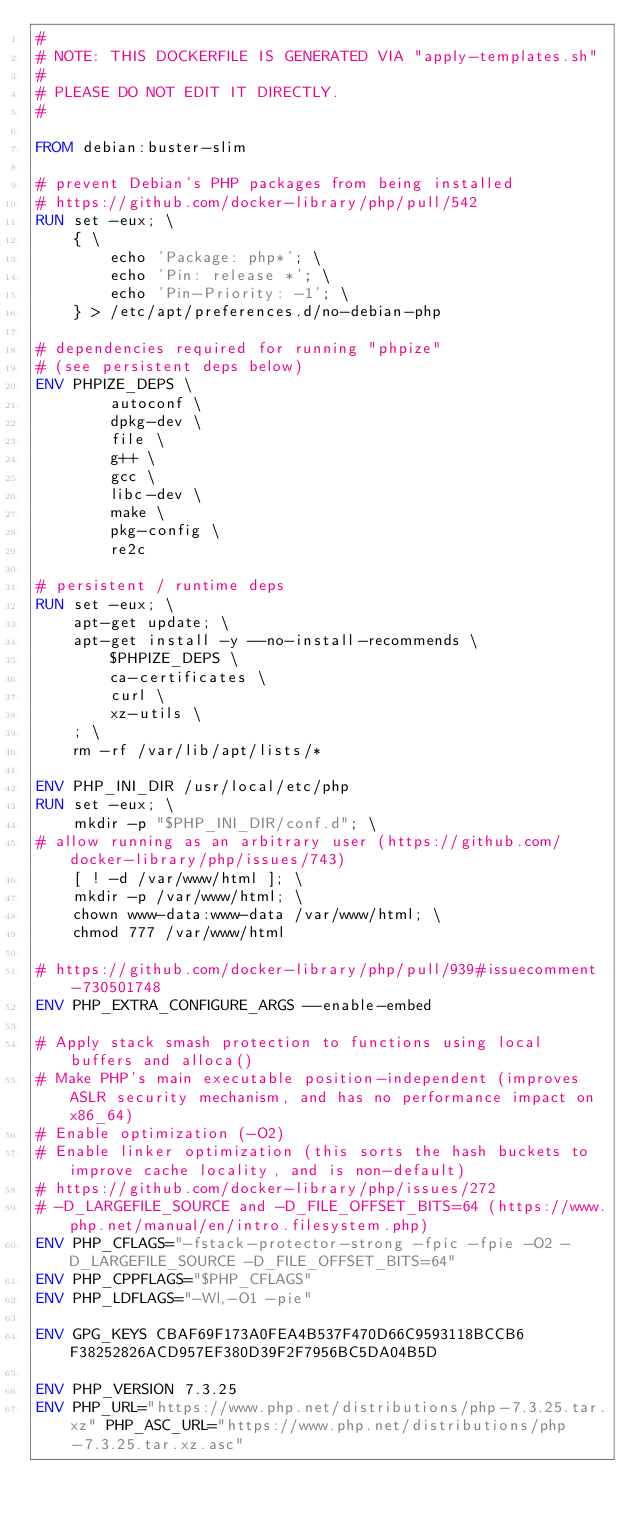<code> <loc_0><loc_0><loc_500><loc_500><_Dockerfile_>#
# NOTE: THIS DOCKERFILE IS GENERATED VIA "apply-templates.sh"
#
# PLEASE DO NOT EDIT IT DIRECTLY.
#

FROM debian:buster-slim

# prevent Debian's PHP packages from being installed
# https://github.com/docker-library/php/pull/542
RUN set -eux; \
	{ \
		echo 'Package: php*'; \
		echo 'Pin: release *'; \
		echo 'Pin-Priority: -1'; \
	} > /etc/apt/preferences.d/no-debian-php

# dependencies required for running "phpize"
# (see persistent deps below)
ENV PHPIZE_DEPS \
		autoconf \
		dpkg-dev \
		file \
		g++ \
		gcc \
		libc-dev \
		make \
		pkg-config \
		re2c

# persistent / runtime deps
RUN set -eux; \
	apt-get update; \
	apt-get install -y --no-install-recommends \
		$PHPIZE_DEPS \
		ca-certificates \
		curl \
		xz-utils \
	; \
	rm -rf /var/lib/apt/lists/*

ENV PHP_INI_DIR /usr/local/etc/php
RUN set -eux; \
	mkdir -p "$PHP_INI_DIR/conf.d"; \
# allow running as an arbitrary user (https://github.com/docker-library/php/issues/743)
	[ ! -d /var/www/html ]; \
	mkdir -p /var/www/html; \
	chown www-data:www-data /var/www/html; \
	chmod 777 /var/www/html

# https://github.com/docker-library/php/pull/939#issuecomment-730501748
ENV PHP_EXTRA_CONFIGURE_ARGS --enable-embed

# Apply stack smash protection to functions using local buffers and alloca()
# Make PHP's main executable position-independent (improves ASLR security mechanism, and has no performance impact on x86_64)
# Enable optimization (-O2)
# Enable linker optimization (this sorts the hash buckets to improve cache locality, and is non-default)
# https://github.com/docker-library/php/issues/272
# -D_LARGEFILE_SOURCE and -D_FILE_OFFSET_BITS=64 (https://www.php.net/manual/en/intro.filesystem.php)
ENV PHP_CFLAGS="-fstack-protector-strong -fpic -fpie -O2 -D_LARGEFILE_SOURCE -D_FILE_OFFSET_BITS=64"
ENV PHP_CPPFLAGS="$PHP_CFLAGS"
ENV PHP_LDFLAGS="-Wl,-O1 -pie"

ENV GPG_KEYS CBAF69F173A0FEA4B537F470D66C9593118BCCB6 F38252826ACD957EF380D39F2F7956BC5DA04B5D

ENV PHP_VERSION 7.3.25
ENV PHP_URL="https://www.php.net/distributions/php-7.3.25.tar.xz" PHP_ASC_URL="https://www.php.net/distributions/php-7.3.25.tar.xz.asc"</code> 